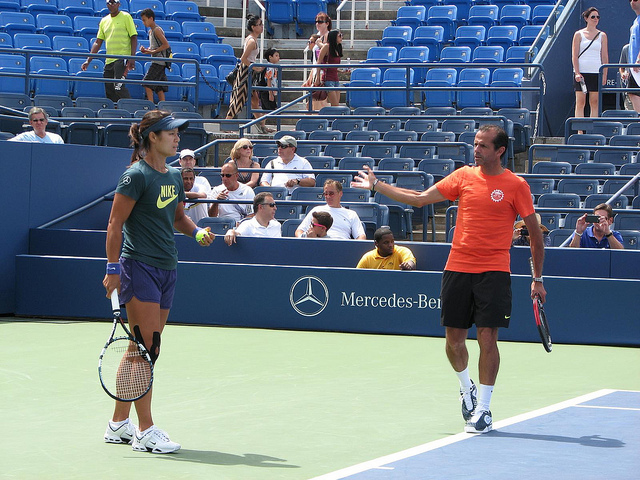Read and extract the text from this image. NIKE Mercedes- Be 